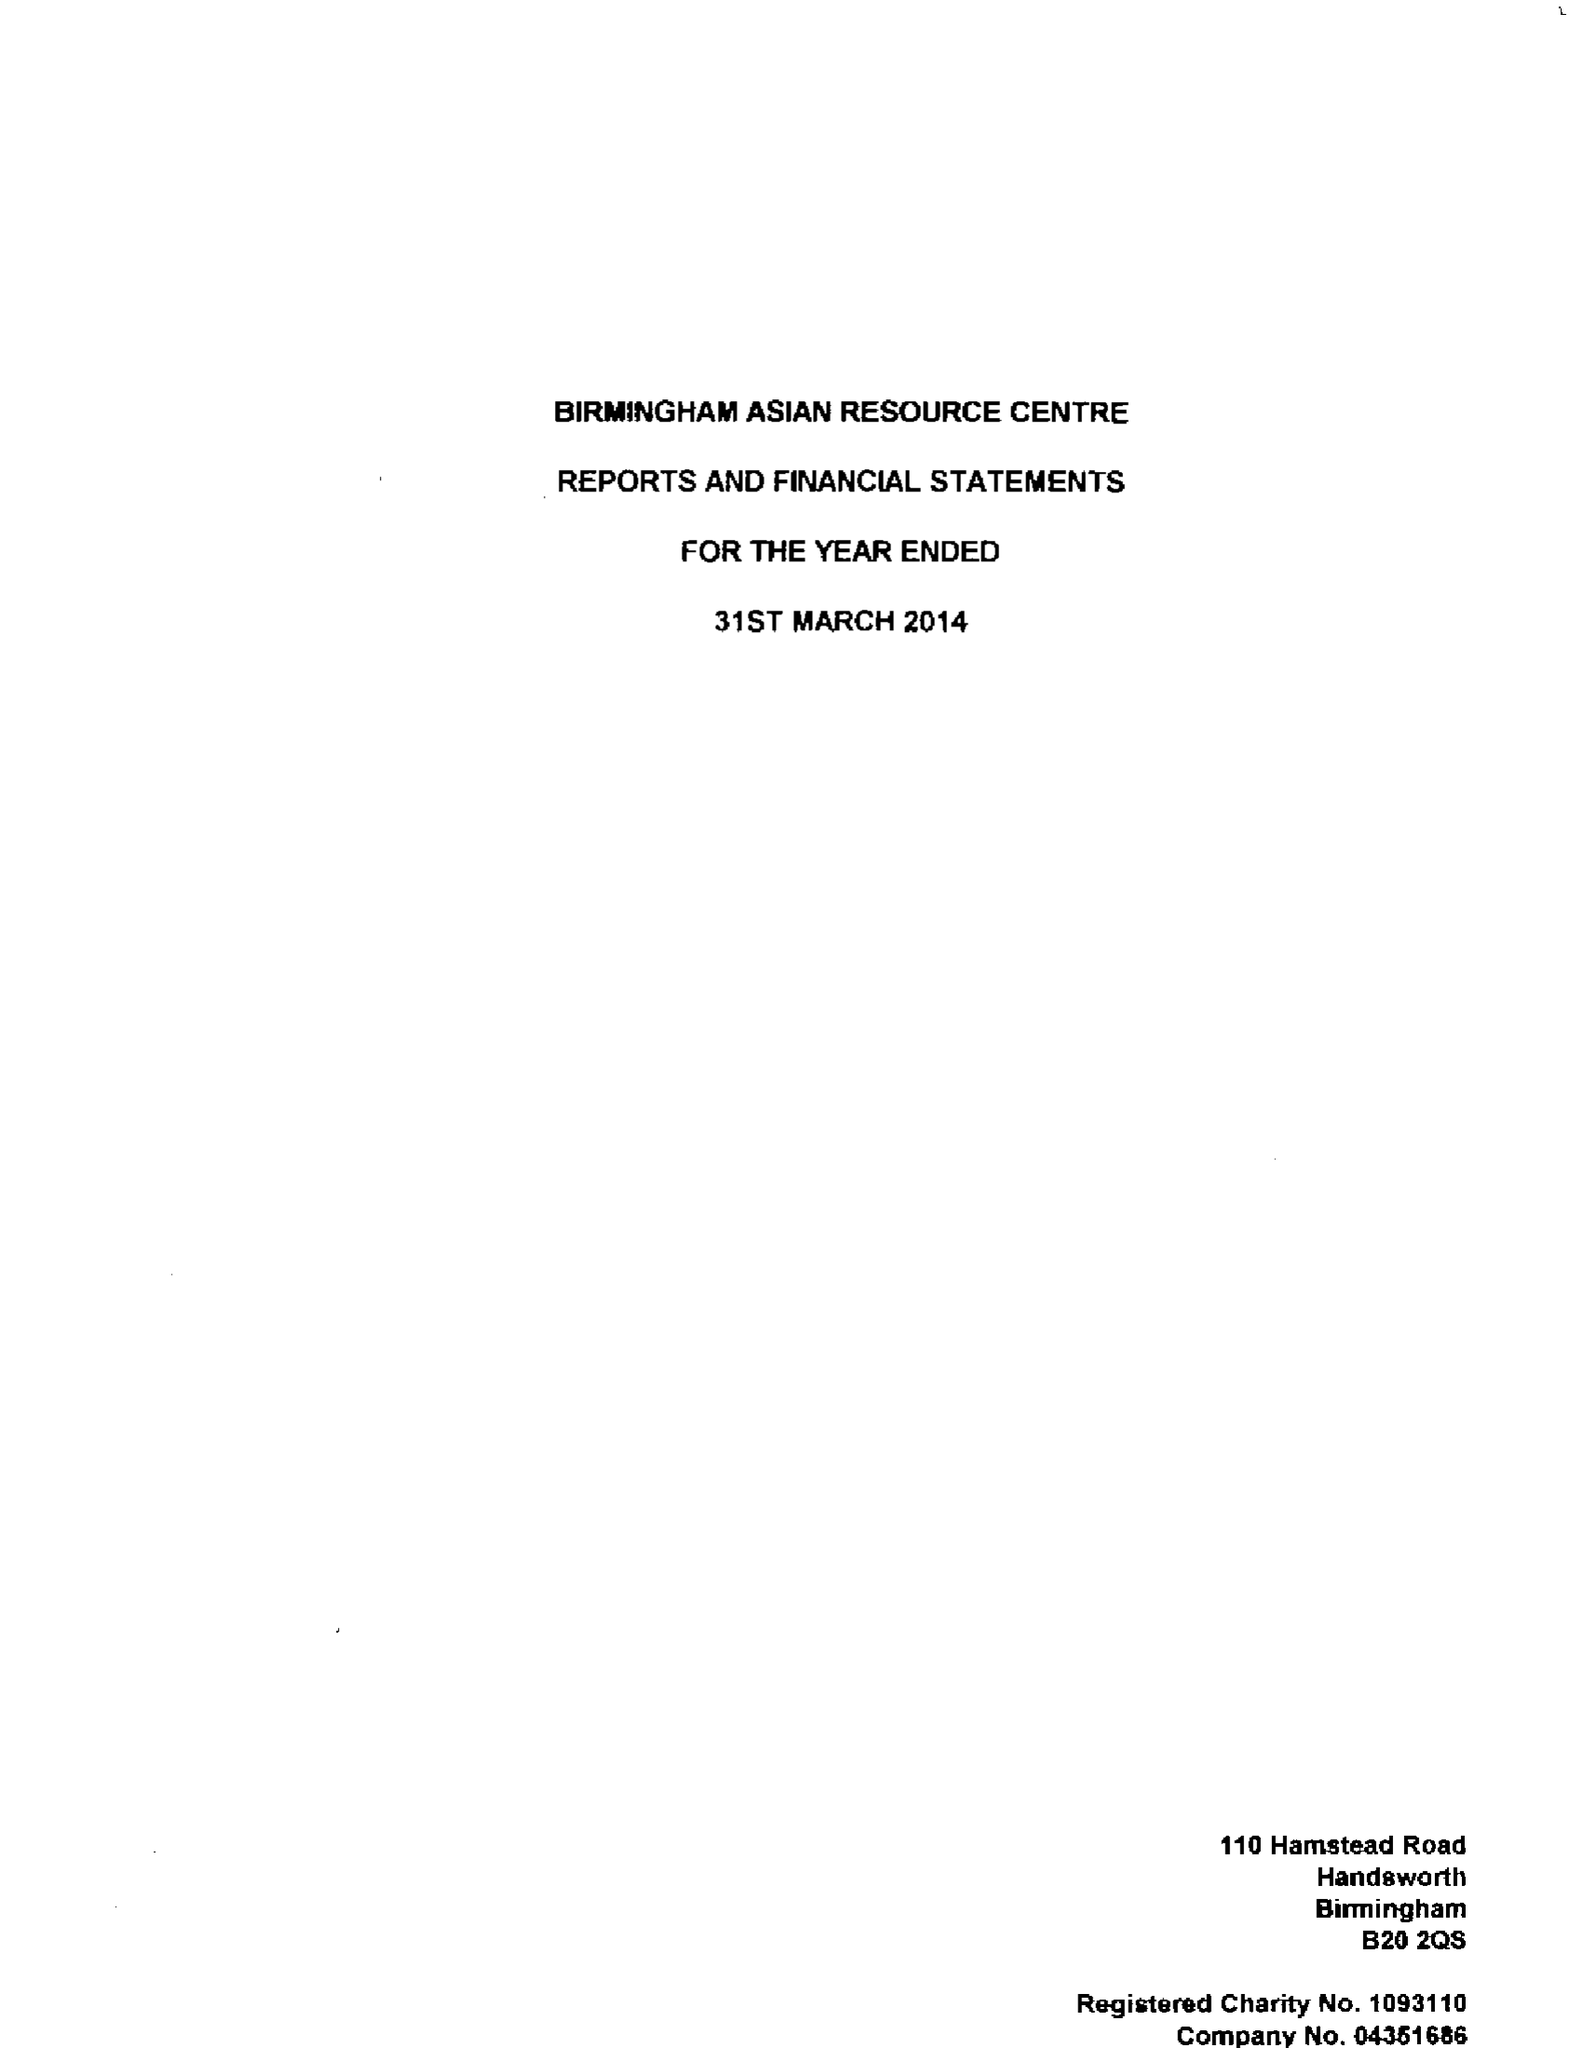What is the value for the spending_annually_in_british_pounds?
Answer the question using a single word or phrase. 272396.00 